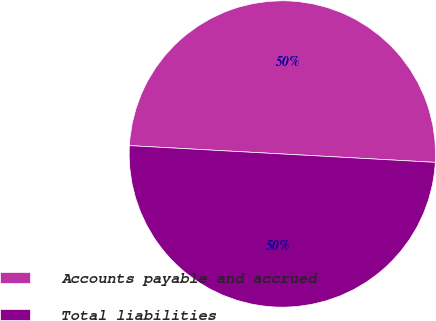Convert chart. <chart><loc_0><loc_0><loc_500><loc_500><pie_chart><fcel>Accounts payable and accrued<fcel>Total liabilities<nl><fcel>50.0%<fcel>50.0%<nl></chart> 